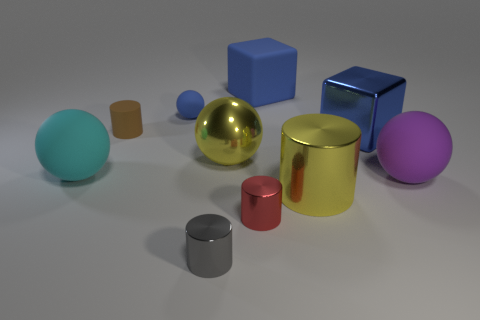There is a small sphere that is the same color as the metallic cube; what is its material?
Offer a very short reply. Rubber. What number of spheres are small blue things or big cyan things?
Your answer should be compact. 2. Is the cyan object made of the same material as the small blue ball?
Provide a short and direct response. Yes. How many other things are the same color as the tiny rubber cylinder?
Provide a short and direct response. 0. The yellow object that is behind the big cyan object has what shape?
Your response must be concise. Sphere. What number of things are shiny spheres or small brown cylinders?
Provide a short and direct response. 2. Do the red shiny cylinder and the block that is behind the rubber cylinder have the same size?
Offer a terse response. No. How many other things are the same material as the tiny red cylinder?
Offer a very short reply. 4. What number of objects are large things that are left of the tiny blue matte thing or big objects in front of the small matte ball?
Keep it short and to the point. 5. There is another big object that is the same shape as the gray thing; what material is it?
Ensure brevity in your answer.  Metal. 